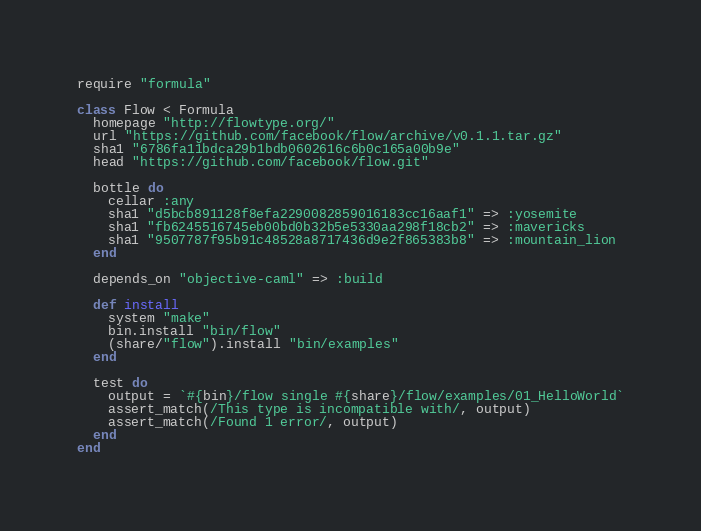<code> <loc_0><loc_0><loc_500><loc_500><_Ruby_>require "formula"

class Flow < Formula
  homepage "http://flowtype.org/"
  url "https://github.com/facebook/flow/archive/v0.1.1.tar.gz"
  sha1 "6786fa11bdca29b1bdb0602616c6b0c165a00b9e"
  head "https://github.com/facebook/flow.git"

  bottle do
    cellar :any
    sha1 "d5bcb891128f8efa2290082859016183cc16aaf1" => :yosemite
    sha1 "fb6245516745eb00bd0b32b5e5330aa298f18cb2" => :mavericks
    sha1 "9507787f95b91c48528a8717436d9e2f865383b8" => :mountain_lion
  end

  depends_on "objective-caml" => :build

  def install
    system "make"
    bin.install "bin/flow"
    (share/"flow").install "bin/examples"
  end

  test do
    output = `#{bin}/flow single #{share}/flow/examples/01_HelloWorld`
    assert_match(/This type is incompatible with/, output)
    assert_match(/Found 1 error/, output)
  end
end
</code> 